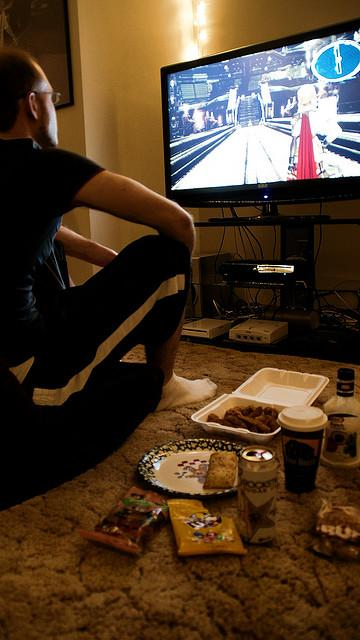What type dressing does this man favor? Please explain your reasoning. ranch. You can tell by the wings he is eating as to what type of dipping sauce he prefers. 